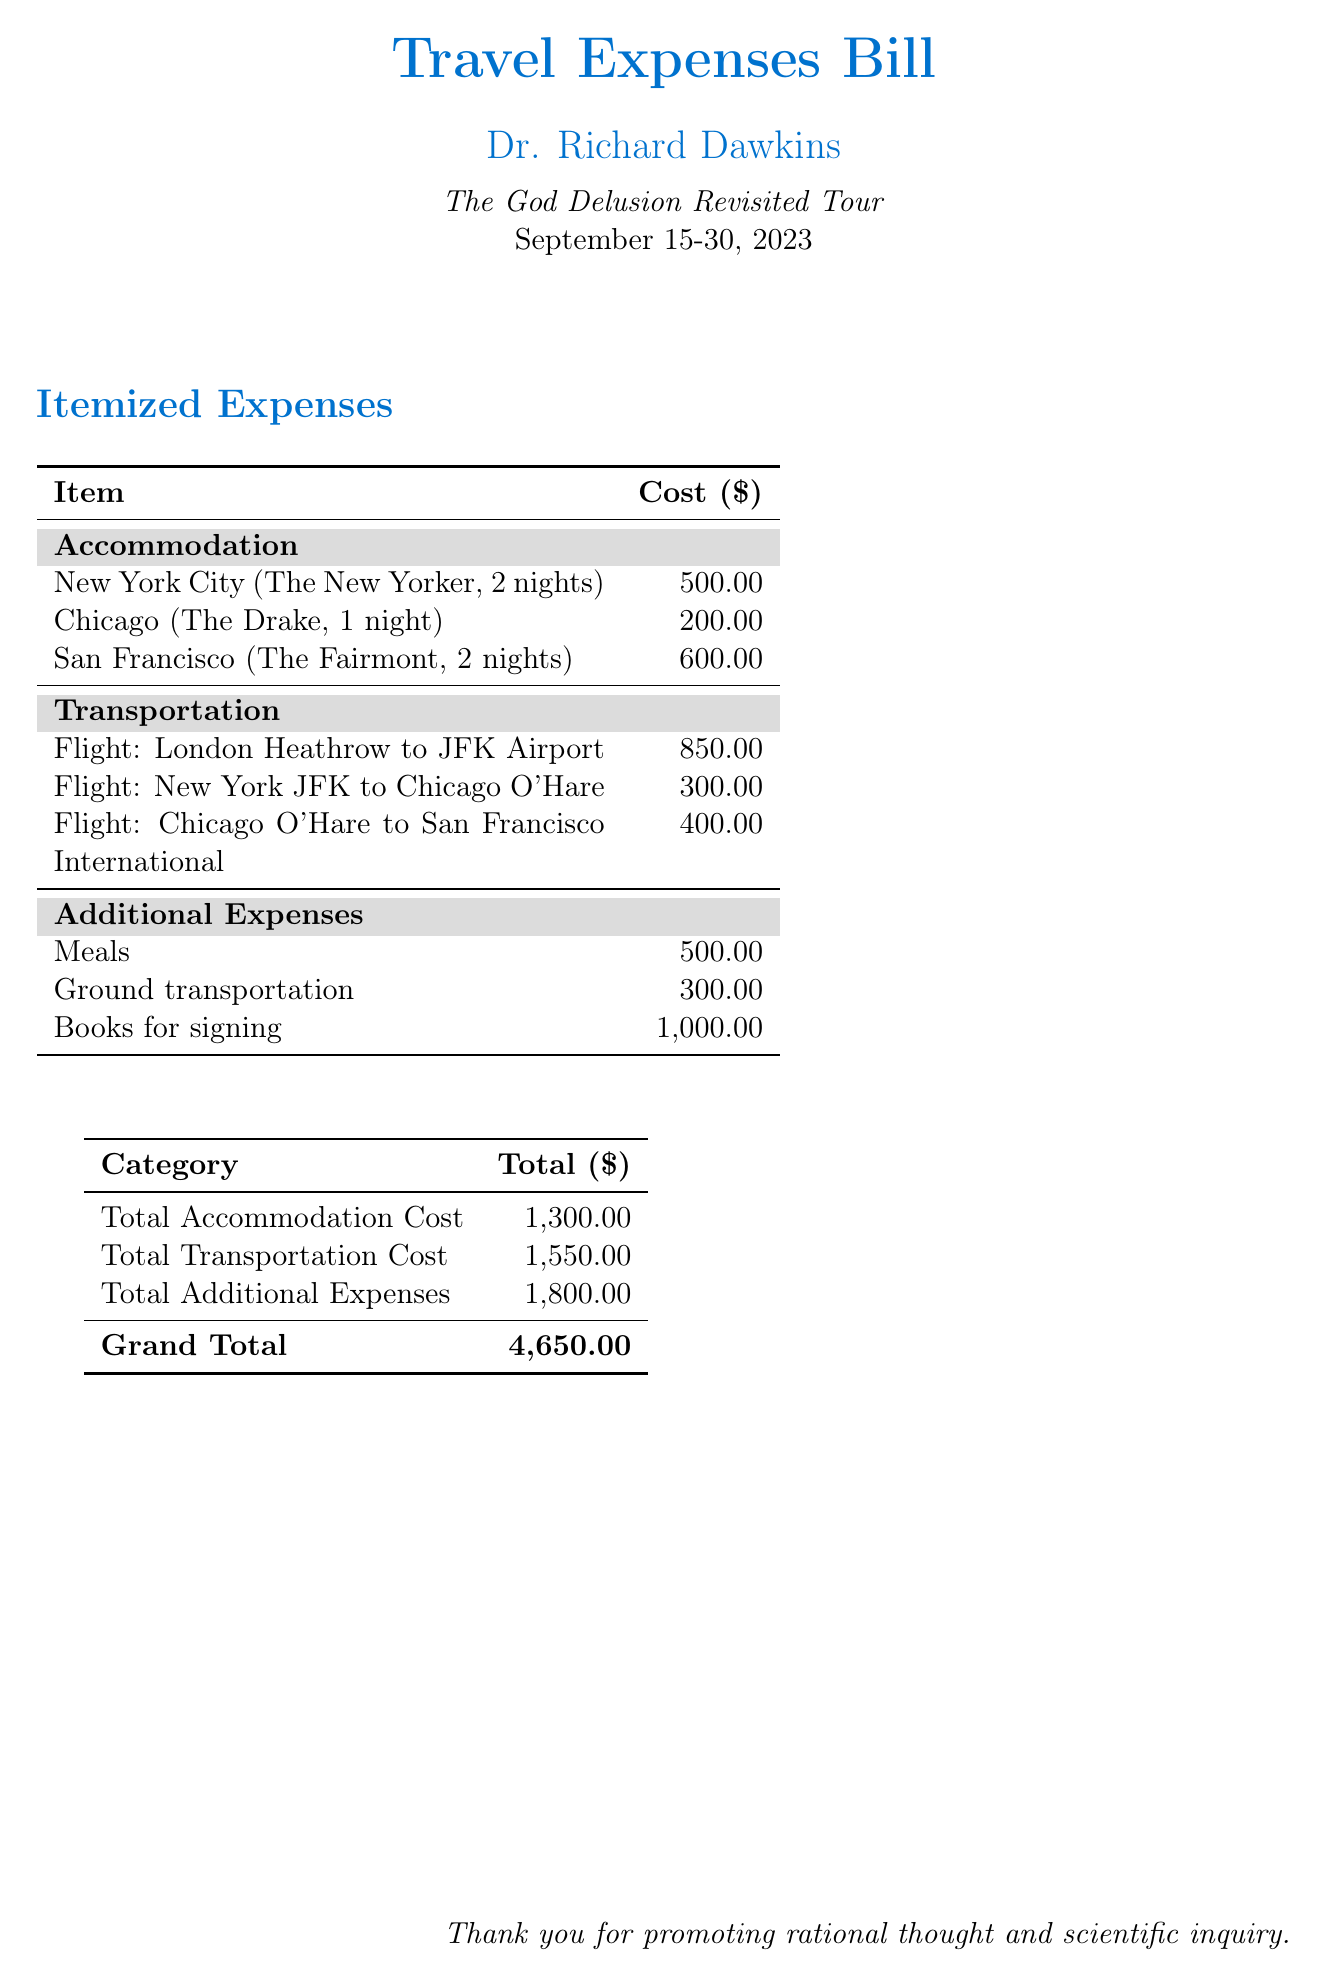What is the total accommodation cost? The total accommodation cost is listed separately in the document as the sum of the individual accommodation expenses.
Answer: 1,300.00 How many nights did Dr. Dawkins stay in New York City? The document specifies that Dr. Dawkins stayed for a total of 2 nights in New York City.
Answer: 2 nights What is the cost of the flight from London Heathrow to JFK Airport? The document lists the flight cost from London Heathrow to JFK Airport specifically as an item.
Answer: 850.00 What city had the highest accommodation cost? The accommodation costs are detailed for each city, with San Francisco having the highest expense of 600.00.
Answer: San Francisco What are the total additional expenses? The total additional expenses are summarized at the end of the document and include various costs.
Answer: 1,800.00 How many flights are listed in the transportation section? The document clearly mentions three flights under the transportation section, providing specific details for each.
Answer: 3 What is the grand total for all expenses? The grand total is clearly indicated at the bottom of the expense table as the overall sum of all categories combined.
Answer: 4,650.00 Which hotel did Dr. Dawkins stay at in Chicago? The document explicitly states the hotel name along with the accommodation cost for the stay in Chicago.
Answer: The Drake 